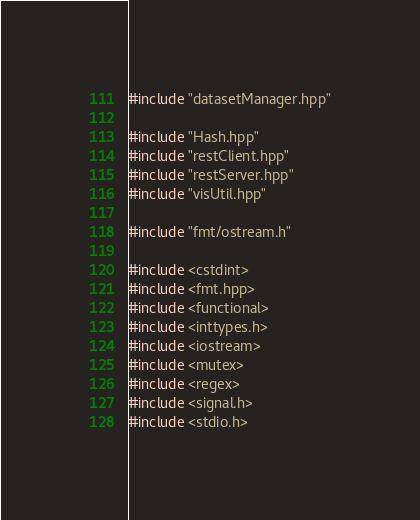<code> <loc_0><loc_0><loc_500><loc_500><_C++_>#include "datasetManager.hpp"

#include "Hash.hpp"
#include "restClient.hpp"
#include "restServer.hpp"
#include "visUtil.hpp"

#include "fmt/ostream.h"

#include <cstdint>
#include <fmt.hpp>
#include <functional>
#include <inttypes.h>
#include <iostream>
#include <mutex>
#include <regex>
#include <signal.h>
#include <stdio.h></code> 